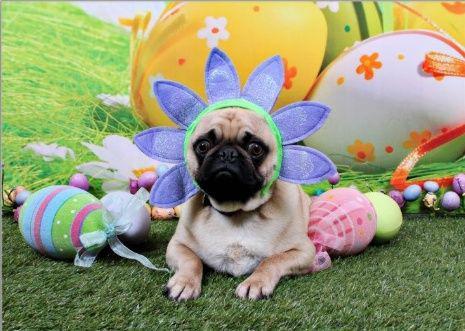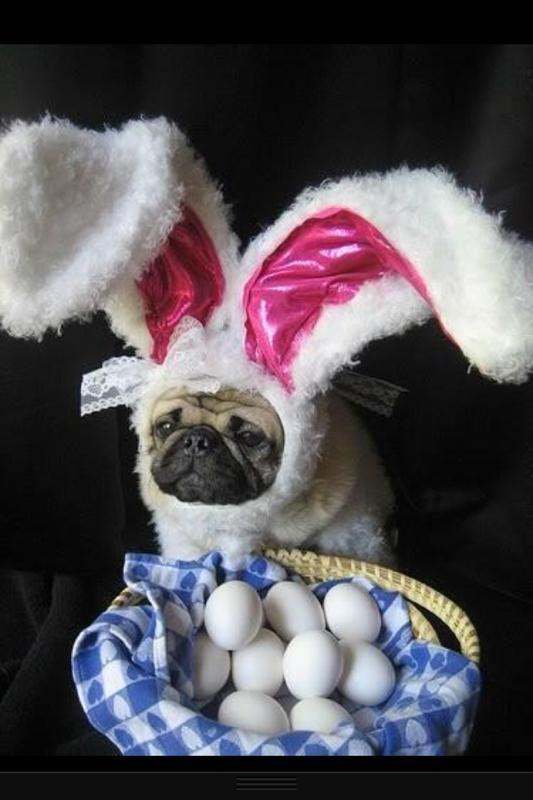The first image is the image on the left, the second image is the image on the right. Considering the images on both sides, is "there is a pug  wearing costume bunny ears laying next to a stuffed bunny toy" valid? Answer yes or no. No. The first image is the image on the left, the second image is the image on the right. Given the left and right images, does the statement "The left image shows a pug wearing bunny ears by a stuffed toy with bunny ears." hold true? Answer yes or no. No. 